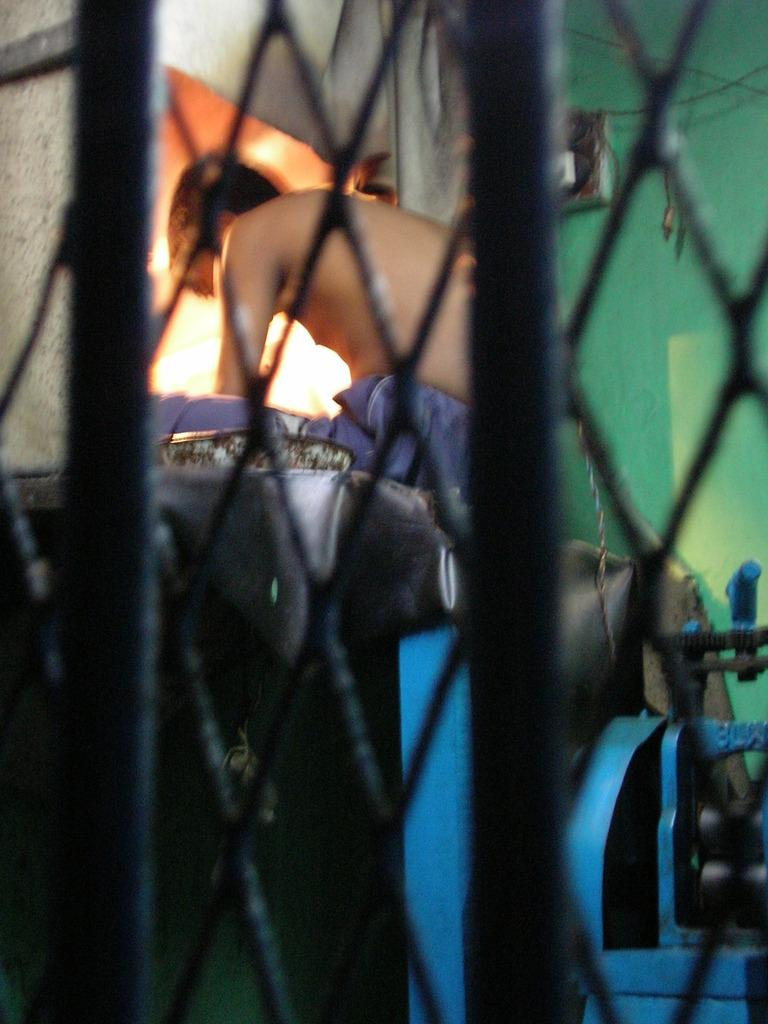What is the person in the image doing? There is a person sitting in the image. What objects can be seen in the image that resemble long, thin bars? There are rods in the image. What type of equipment is present in the image? There is a machine in the image. What type of container is present in the image? There is a box in the image. Can you describe any other objects in the image that are not specified? There are some unspecified objects in the image. What can be seen in the background of the image? There is a wall in the background of the image. Can you see any horses wearing veils in the image? There are no horses or veils present in the image. 